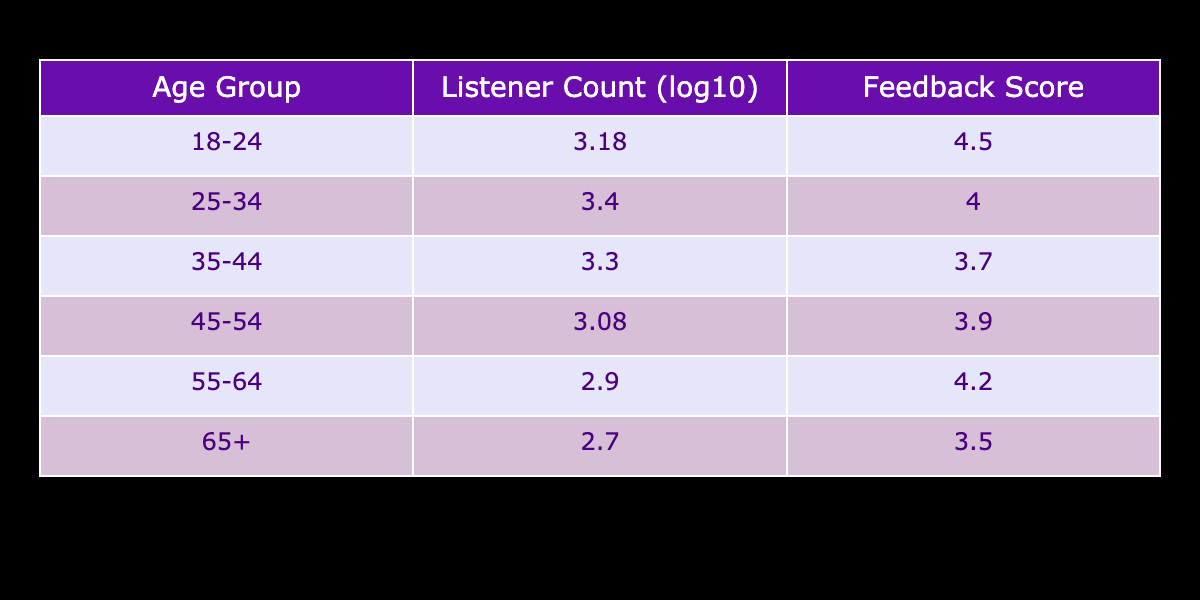What is the feedback score for the age group 25-34? Looking at the "Feedback Score" column, the score for the age group 25-34 is listed directly in the table under that age category.
Answer: 4.0 What is the logarithmic value of the listener count for the age group 18-24? The table provides the logarithmic transformation of the listener count for each age group. For 18-24, the listener count is 1500, and the logarithmic value is calculated as log10(1500), which rounds to approximately 3.18.
Answer: 3.18 Which age group has the highest feedback score, and what is that score? By comparing the "Feedback Score" values in the table, the age group 18-24 has the highest score of 4.5.
Answer: 18-24, 4.5 Is the feedback score for listeners aged 45-54 higher than that for listeners aged 55-64? By comparing the two feedback scores found in the table, the score for 45-54 is 3.9, and for 55-64, it is 4.2. Since 4.2 is higher than 3.9, the answer is no.
Answer: No What is the total number of listeners for all age groups combined? To find the total listeners, we sum the listener counts from all age groups: 1500 + 2500 + 2000 + 1200 + 800 + 500 = 10,500.
Answer: 10,500 What is the average feedback score across all age groups? To calculate the average feedback score, we sum up the feedback scores (4.5 + 4.0 + 3.7 + 3.9 + 4.2 + 3.5 = 24.8) and then divide by the number of age groups (6), yielding an average of about 4.13.
Answer: 4.13 Does the age group 65 and older have the lowest listener count? By looking at the listener counts in the "Listener Count" column, we can see that the age group 65+ has 500 listeners, which is lower than all other age groups. Thus, the answer is yes.
Answer: Yes Which age group has the lowest feedback score, and what is that score? Examining the feedback scores in the table indicates that the age group 65+ has the lowest score, which is 3.5.
Answer: 65+, 3.5 